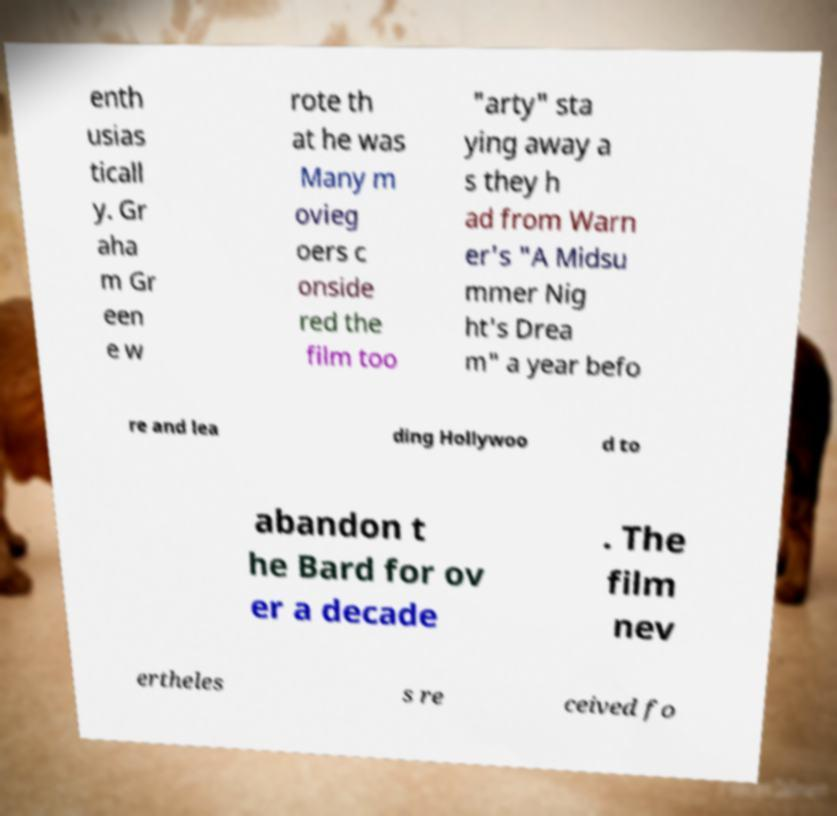Can you read and provide the text displayed in the image?This photo seems to have some interesting text. Can you extract and type it out for me? enth usias ticall y. Gr aha m Gr een e w rote th at he was Many m ovieg oers c onside red the film too "arty" sta ying away a s they h ad from Warn er's "A Midsu mmer Nig ht's Drea m" a year befo re and lea ding Hollywoo d to abandon t he Bard for ov er a decade . The film nev ertheles s re ceived fo 